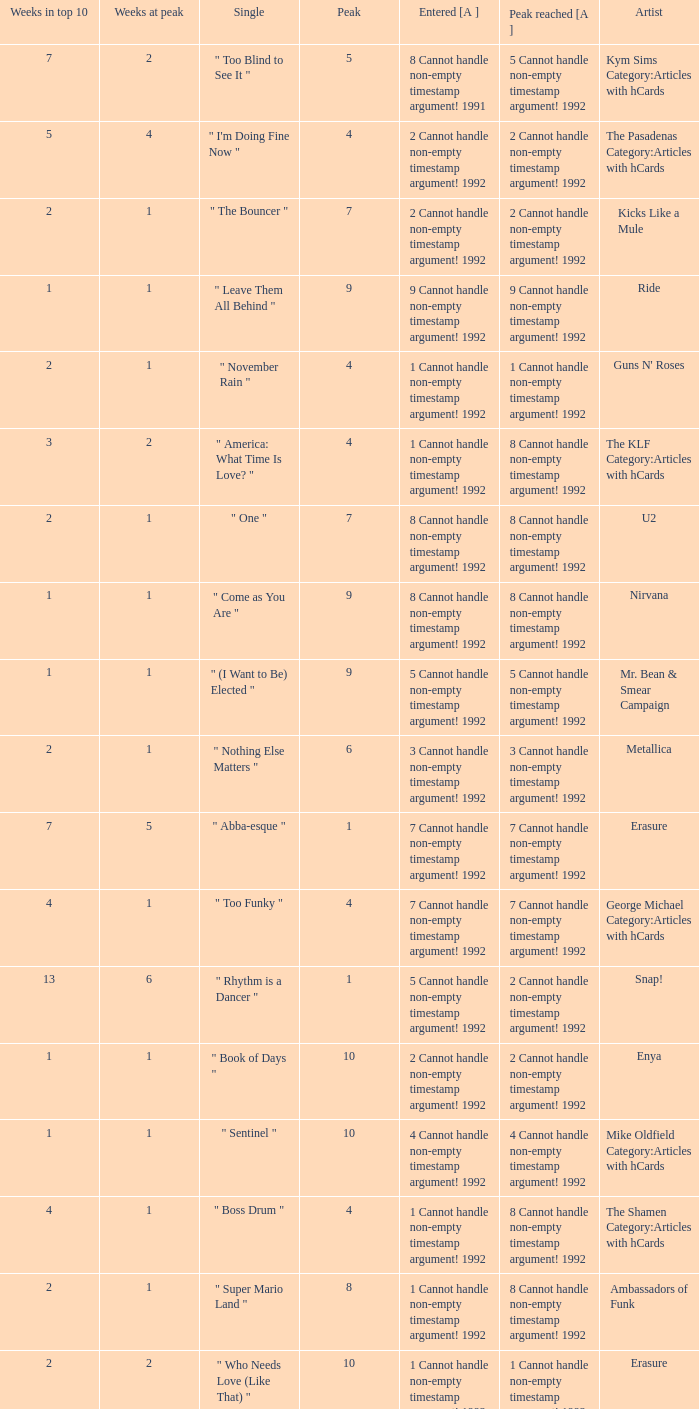If the peak is 9, how many weeks was it in the top 10? 1.0. 